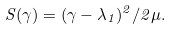<formula> <loc_0><loc_0><loc_500><loc_500>S ( \gamma ) = ( \gamma - \lambda _ { 1 } ) ^ { 2 } / 2 \mu .</formula> 